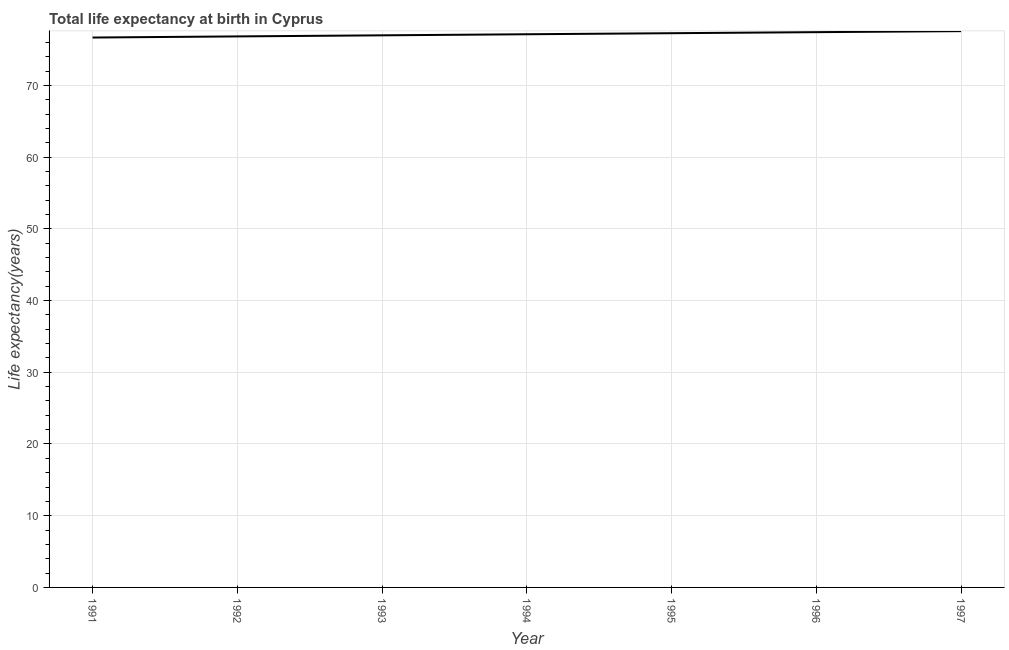What is the life expectancy at birth in 1993?
Give a very brief answer. 76.98. Across all years, what is the maximum life expectancy at birth?
Offer a very short reply. 77.56. Across all years, what is the minimum life expectancy at birth?
Offer a very short reply. 76.67. In which year was the life expectancy at birth minimum?
Provide a short and direct response. 1991. What is the sum of the life expectancy at birth?
Give a very brief answer. 539.86. What is the difference between the life expectancy at birth in 1991 and 1994?
Keep it short and to the point. -0.46. What is the average life expectancy at birth per year?
Your answer should be compact. 77.12. What is the median life expectancy at birth?
Provide a short and direct response. 77.13. What is the ratio of the life expectancy at birth in 1992 to that in 1994?
Give a very brief answer. 1. What is the difference between the highest and the second highest life expectancy at birth?
Your response must be concise. 0.14. Is the sum of the life expectancy at birth in 1996 and 1997 greater than the maximum life expectancy at birth across all years?
Provide a succinct answer. Yes. What is the difference between the highest and the lowest life expectancy at birth?
Your response must be concise. 0.89. How many lines are there?
Give a very brief answer. 1. What is the difference between two consecutive major ticks on the Y-axis?
Ensure brevity in your answer.  10. What is the title of the graph?
Ensure brevity in your answer.  Total life expectancy at birth in Cyprus. What is the label or title of the Y-axis?
Your answer should be very brief. Life expectancy(years). What is the Life expectancy(years) in 1991?
Make the answer very short. 76.67. What is the Life expectancy(years) of 1992?
Make the answer very short. 76.83. What is the Life expectancy(years) of 1993?
Offer a very short reply. 76.98. What is the Life expectancy(years) of 1994?
Offer a terse response. 77.13. What is the Life expectancy(years) of 1995?
Your answer should be compact. 77.27. What is the Life expectancy(years) of 1996?
Provide a short and direct response. 77.42. What is the Life expectancy(years) in 1997?
Your answer should be compact. 77.56. What is the difference between the Life expectancy(years) in 1991 and 1992?
Provide a short and direct response. -0.15. What is the difference between the Life expectancy(years) in 1991 and 1993?
Keep it short and to the point. -0.31. What is the difference between the Life expectancy(years) in 1991 and 1994?
Offer a very short reply. -0.46. What is the difference between the Life expectancy(years) in 1991 and 1995?
Give a very brief answer. -0.6. What is the difference between the Life expectancy(years) in 1991 and 1996?
Your response must be concise. -0.75. What is the difference between the Life expectancy(years) in 1991 and 1997?
Your answer should be compact. -0.89. What is the difference between the Life expectancy(years) in 1992 and 1993?
Your answer should be very brief. -0.15. What is the difference between the Life expectancy(years) in 1992 and 1994?
Your answer should be very brief. -0.3. What is the difference between the Life expectancy(years) in 1992 and 1995?
Offer a very short reply. -0.45. What is the difference between the Life expectancy(years) in 1992 and 1996?
Provide a succinct answer. -0.59. What is the difference between the Life expectancy(years) in 1992 and 1997?
Make the answer very short. -0.73. What is the difference between the Life expectancy(years) in 1993 and 1994?
Your response must be concise. -0.15. What is the difference between the Life expectancy(years) in 1993 and 1995?
Your answer should be very brief. -0.3. What is the difference between the Life expectancy(years) in 1993 and 1996?
Make the answer very short. -0.44. What is the difference between the Life expectancy(years) in 1993 and 1997?
Your answer should be very brief. -0.58. What is the difference between the Life expectancy(years) in 1994 and 1995?
Provide a succinct answer. -0.15. What is the difference between the Life expectancy(years) in 1994 and 1996?
Provide a succinct answer. -0.29. What is the difference between the Life expectancy(years) in 1994 and 1997?
Make the answer very short. -0.43. What is the difference between the Life expectancy(years) in 1995 and 1996?
Offer a very short reply. -0.14. What is the difference between the Life expectancy(years) in 1995 and 1997?
Provide a succinct answer. -0.29. What is the difference between the Life expectancy(years) in 1996 and 1997?
Offer a very short reply. -0.14. What is the ratio of the Life expectancy(years) in 1991 to that in 1993?
Your response must be concise. 1. What is the ratio of the Life expectancy(years) in 1991 to that in 1994?
Give a very brief answer. 0.99. What is the ratio of the Life expectancy(years) in 1991 to that in 1995?
Ensure brevity in your answer.  0.99. What is the ratio of the Life expectancy(years) in 1991 to that in 1996?
Provide a short and direct response. 0.99. What is the ratio of the Life expectancy(years) in 1992 to that in 1994?
Provide a succinct answer. 1. What is the ratio of the Life expectancy(years) in 1993 to that in 1994?
Offer a terse response. 1. 